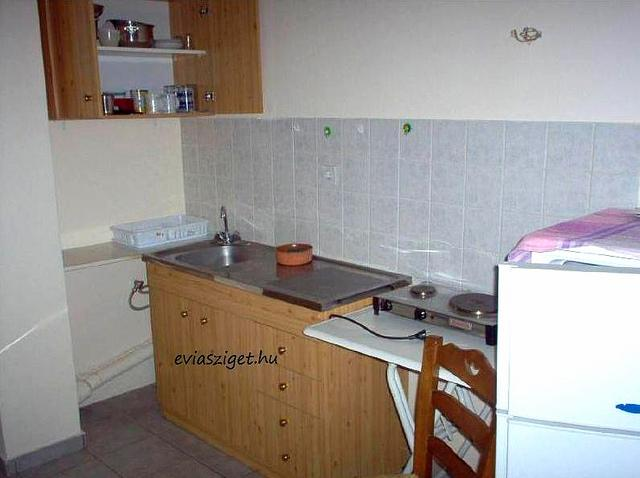What country is this? Please explain your reasoning. hungary. The website says .hu, which is short for hungary. 